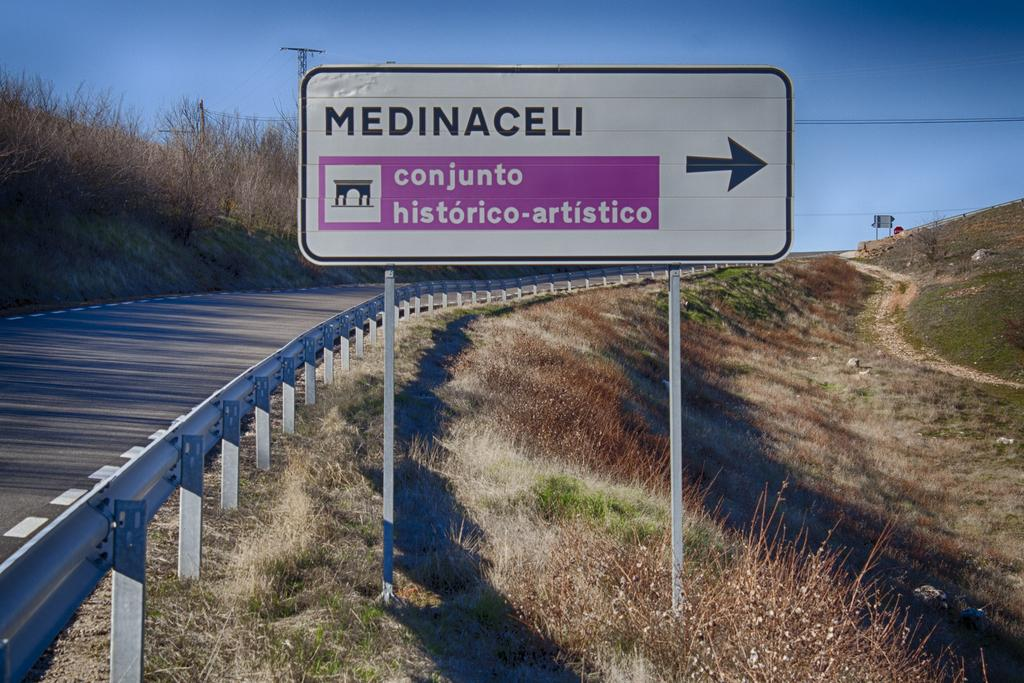<image>
Write a terse but informative summary of the picture. A sign for Medinaceli has an arrow that points to the right. 